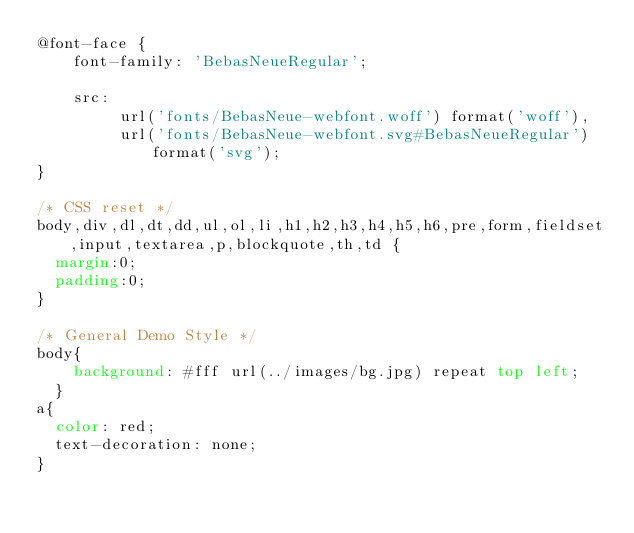<code> <loc_0><loc_0><loc_500><loc_500><_CSS_>@font-face {
    font-family: 'BebasNeueRegular';
    
    src: 
         url('fonts/BebasNeue-webfont.woff') format('woff'),
         url('fonts/BebasNeue-webfont.svg#BebasNeueRegular') format('svg');  
}

/* CSS reset */
body,div,dl,dt,dd,ul,ol,li,h1,h2,h3,h4,h5,h6,pre,form,fieldset,input,textarea,p,blockquote,th,td { 
	margin:0;
	padding:0;
}

/* General Demo Style */
body{
		background: #fff url(../images/bg.jpg) repeat top left;
	}
a{
	color: red;
	text-decoration: none;
}</code> 